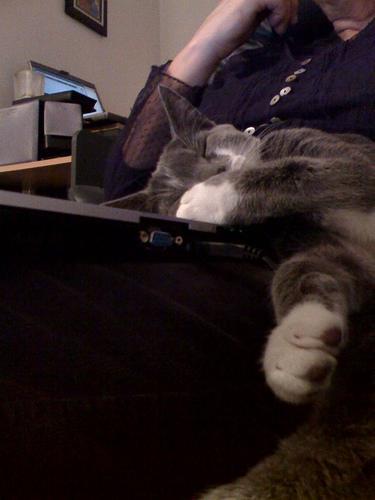How many laptops are there?
Give a very brief answer. 1. How many bears are on the ground?
Give a very brief answer. 0. 